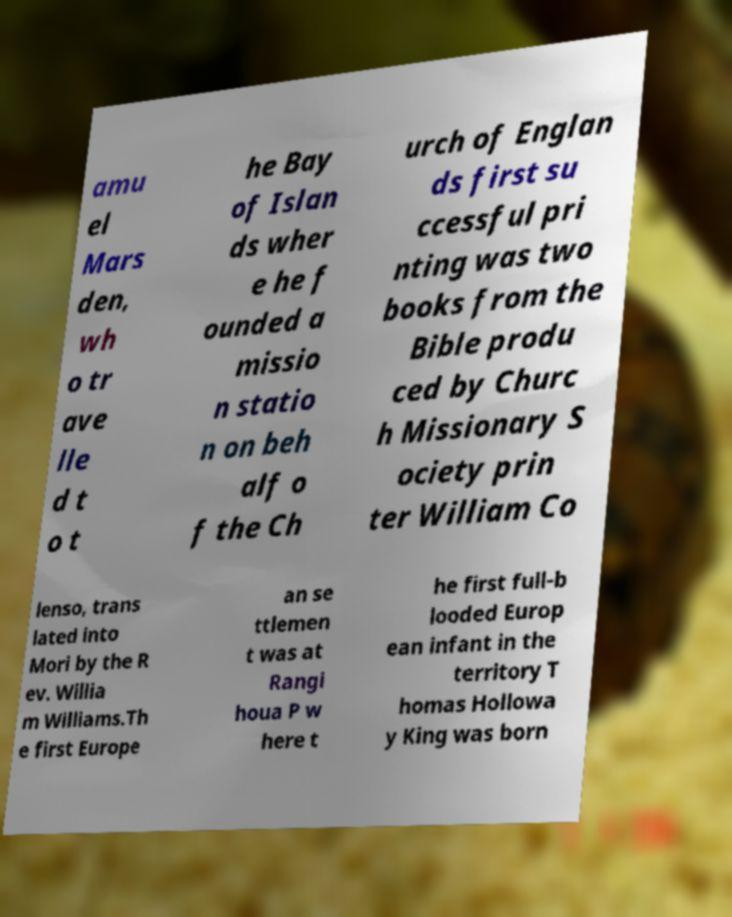There's text embedded in this image that I need extracted. Can you transcribe it verbatim? amu el Mars den, wh o tr ave lle d t o t he Bay of Islan ds wher e he f ounded a missio n statio n on beh alf o f the Ch urch of Englan ds first su ccessful pri nting was two books from the Bible produ ced by Churc h Missionary S ociety prin ter William Co lenso, trans lated into Mori by the R ev. Willia m Williams.Th e first Europe an se ttlemen t was at Rangi houa P w here t he first full-b looded Europ ean infant in the territory T homas Hollowa y King was born 